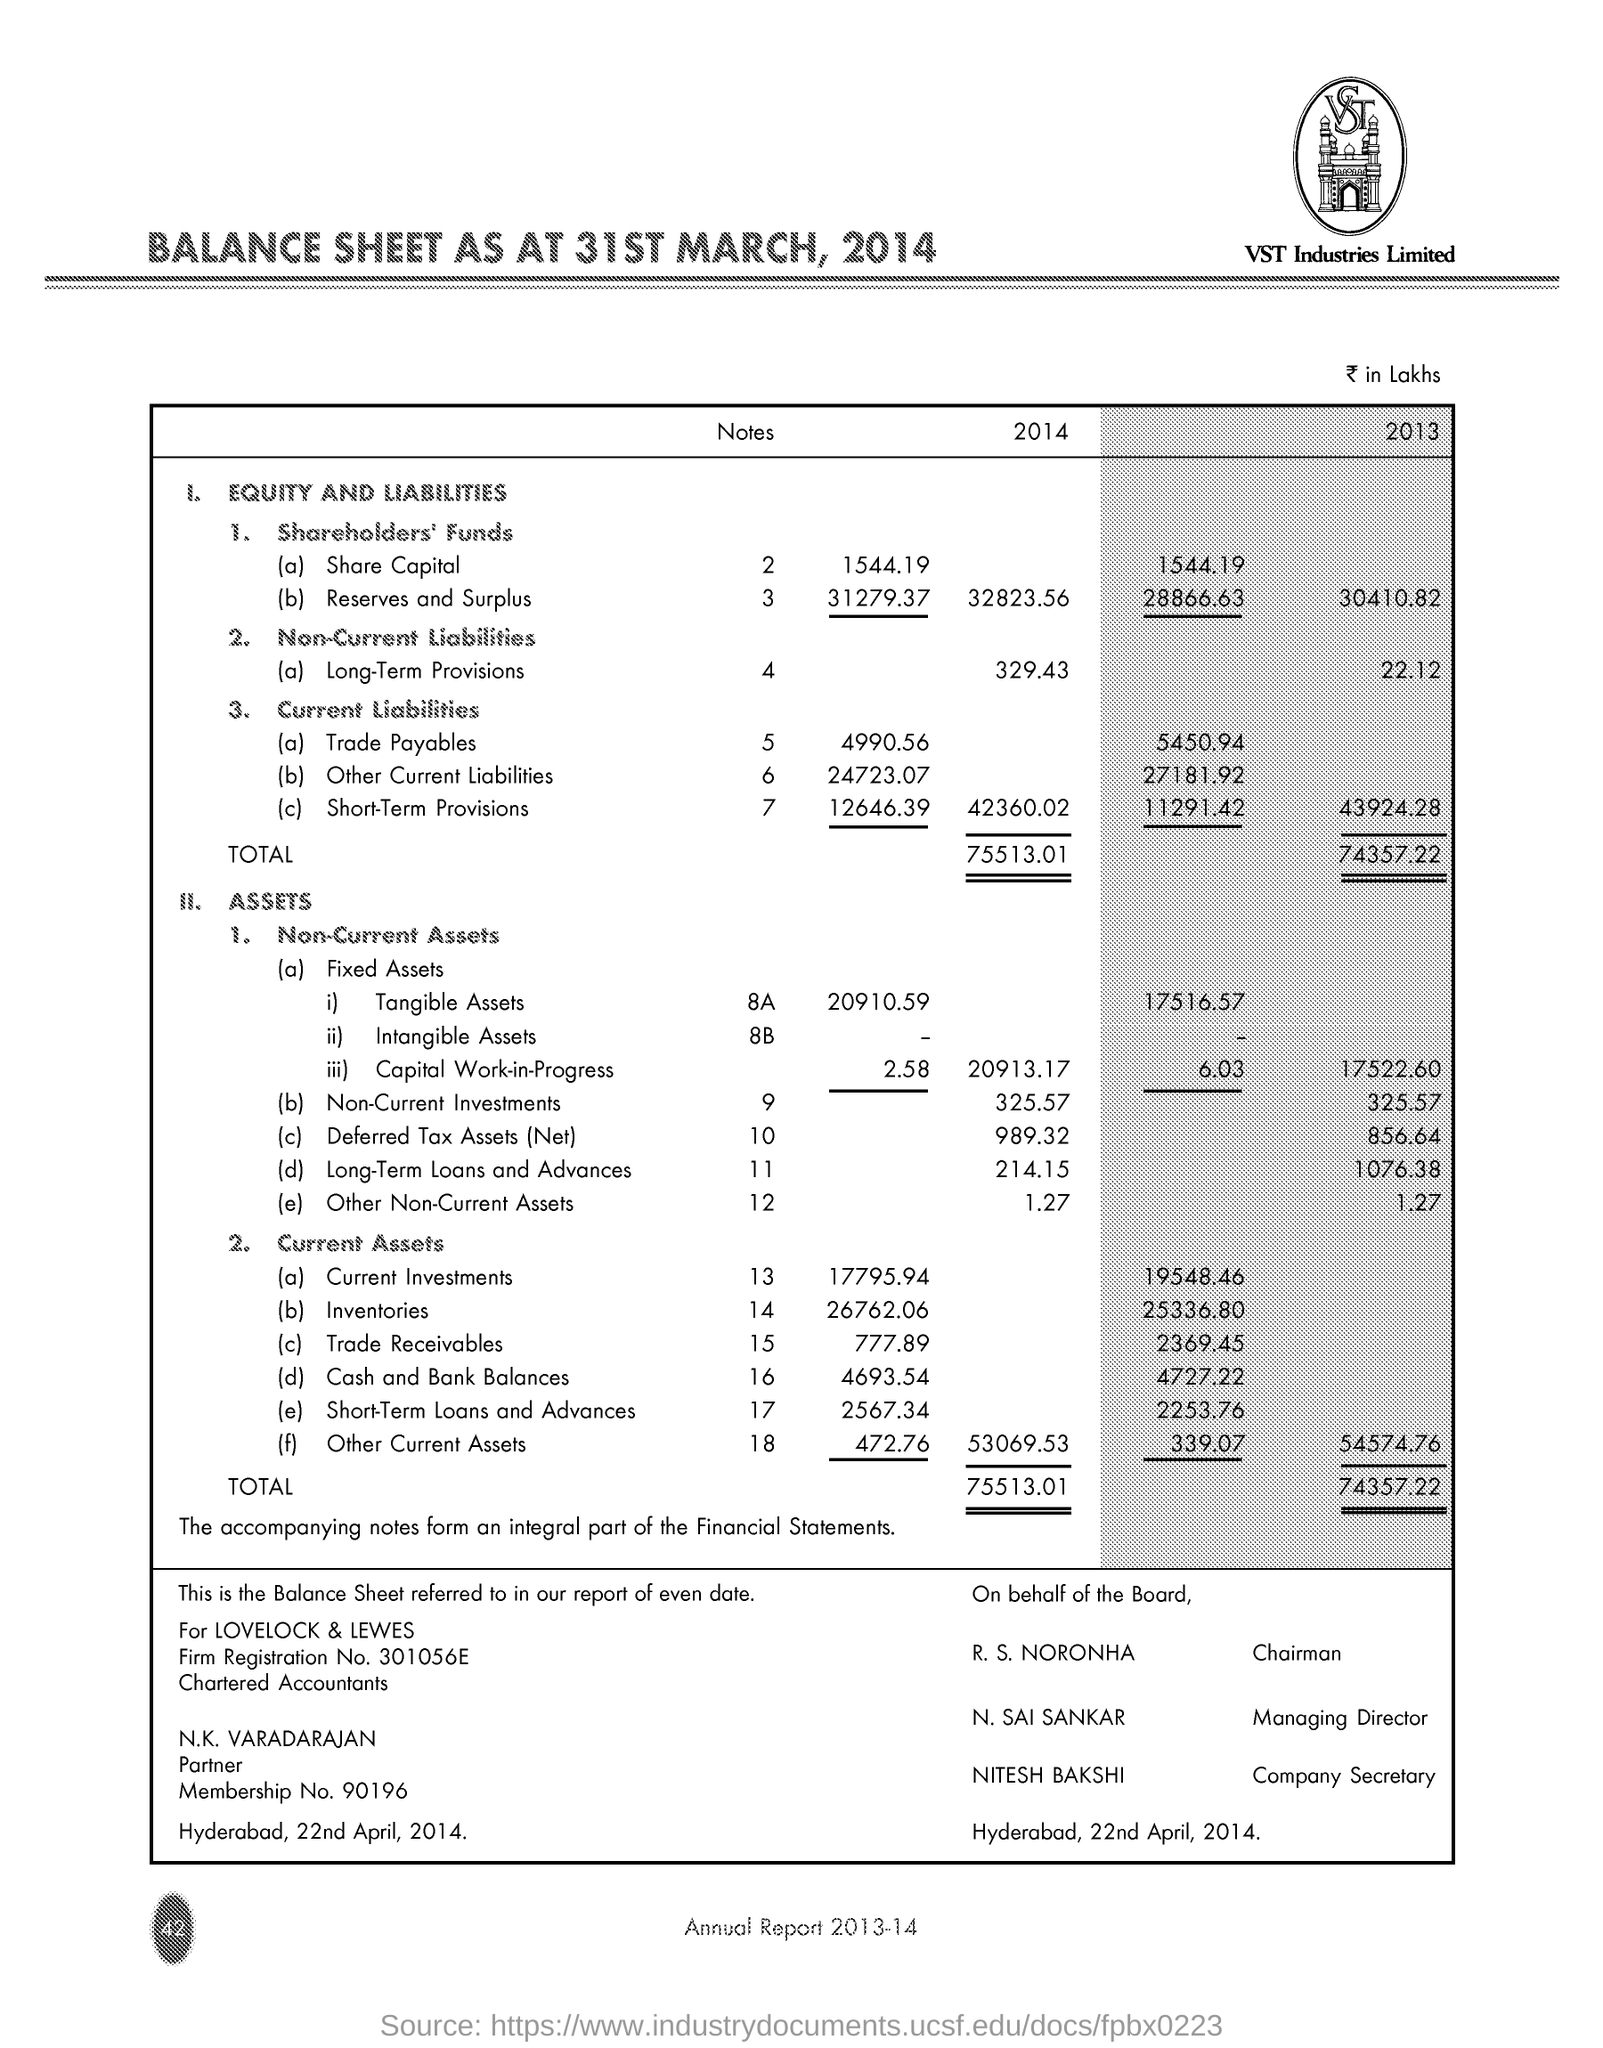Outline some significant characteristics in this image. The document is dated on April 22, 2014. The company secretary is named Nitesh Bakshi. The Chairman is R. S. Noronha. The managing director is N. Sai Sankar. The "Total" assets for the year 2013 were 74,357.22. 